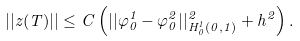Convert formula to latex. <formula><loc_0><loc_0><loc_500><loc_500>| | z ( T ) | | \leq C \left ( | | \varphi ^ { 1 } _ { 0 } - \varphi ^ { 2 } _ { 0 } | | ^ { 2 } _ { H ^ { 1 } _ { 0 } ( 0 , 1 ) } + h ^ { 2 } \right ) .</formula> 